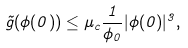Convert formula to latex. <formula><loc_0><loc_0><loc_500><loc_500>\tilde { g } ( \phi ( 0 ) ) \leq \mu _ { c } \frac { 1 } { \phi _ { 0 } } | \phi ( 0 ) | ^ { 3 } ,</formula> 